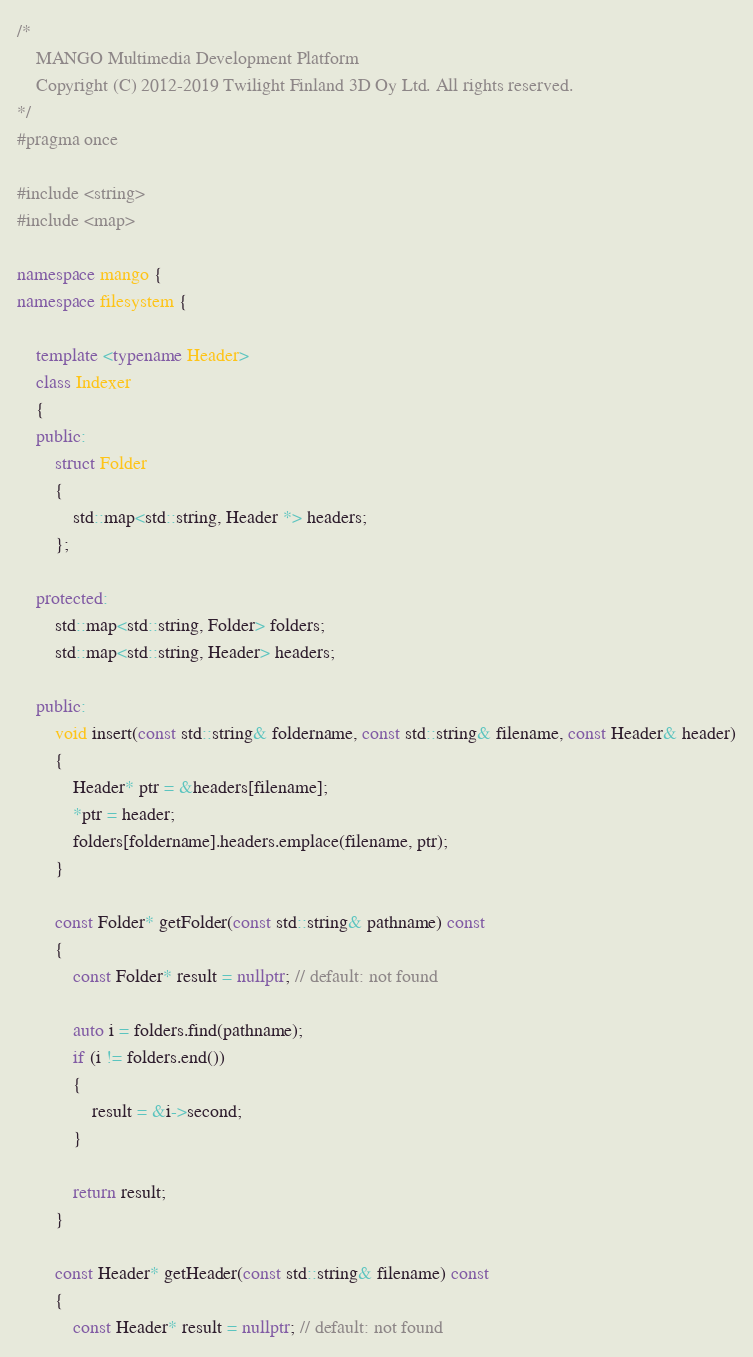Convert code to text. <code><loc_0><loc_0><loc_500><loc_500><_C++_>/*
    MANGO Multimedia Development Platform
    Copyright (C) 2012-2019 Twilight Finland 3D Oy Ltd. All rights reserved.
*/
#pragma once

#include <string>
#include <map>

namespace mango {
namespace filesystem {

    template <typename Header>
    class Indexer
    {
    public:
        struct Folder
        {
            std::map<std::string, Header *> headers;
        };

    protected:
        std::map<std::string, Folder> folders;
        std::map<std::string, Header> headers;

    public:
        void insert(const std::string& foldername, const std::string& filename, const Header& header)
        {
            Header* ptr = &headers[filename];
            *ptr = header;
            folders[foldername].headers.emplace(filename, ptr);
        }

        const Folder* getFolder(const std::string& pathname) const
        {
            const Folder* result = nullptr; // default: not found

            auto i = folders.find(pathname);
            if (i != folders.end())
            {
                result = &i->second;
            }

            return result;
        }

        const Header* getHeader(const std::string& filename) const
        {
            const Header* result = nullptr; // default: not found
</code> 